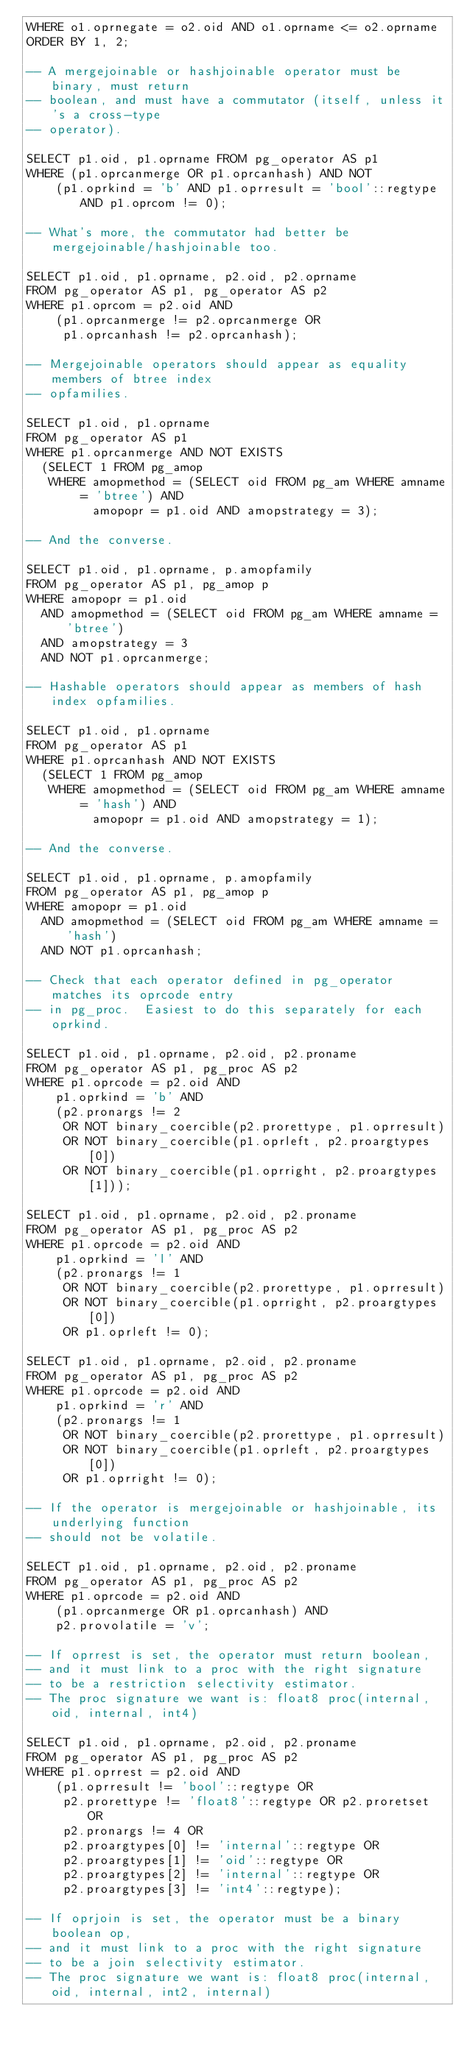<code> <loc_0><loc_0><loc_500><loc_500><_SQL_>WHERE o1.oprnegate = o2.oid AND o1.oprname <= o2.oprname
ORDER BY 1, 2;

-- A mergejoinable or hashjoinable operator must be binary, must return
-- boolean, and must have a commutator (itself, unless it's a cross-type
-- operator).

SELECT p1.oid, p1.oprname FROM pg_operator AS p1
WHERE (p1.oprcanmerge OR p1.oprcanhash) AND NOT
    (p1.oprkind = 'b' AND p1.oprresult = 'bool'::regtype AND p1.oprcom != 0);

-- What's more, the commutator had better be mergejoinable/hashjoinable too.

SELECT p1.oid, p1.oprname, p2.oid, p2.oprname
FROM pg_operator AS p1, pg_operator AS p2
WHERE p1.oprcom = p2.oid AND
    (p1.oprcanmerge != p2.oprcanmerge OR
     p1.oprcanhash != p2.oprcanhash);

-- Mergejoinable operators should appear as equality members of btree index
-- opfamilies.

SELECT p1.oid, p1.oprname
FROM pg_operator AS p1
WHERE p1.oprcanmerge AND NOT EXISTS
  (SELECT 1 FROM pg_amop
   WHERE amopmethod = (SELECT oid FROM pg_am WHERE amname = 'btree') AND
         amopopr = p1.oid AND amopstrategy = 3);

-- And the converse.

SELECT p1.oid, p1.oprname, p.amopfamily
FROM pg_operator AS p1, pg_amop p
WHERE amopopr = p1.oid
  AND amopmethod = (SELECT oid FROM pg_am WHERE amname = 'btree')
  AND amopstrategy = 3
  AND NOT p1.oprcanmerge;

-- Hashable operators should appear as members of hash index opfamilies.

SELECT p1.oid, p1.oprname
FROM pg_operator AS p1
WHERE p1.oprcanhash AND NOT EXISTS
  (SELECT 1 FROM pg_amop
   WHERE amopmethod = (SELECT oid FROM pg_am WHERE amname = 'hash') AND
         amopopr = p1.oid AND amopstrategy = 1);

-- And the converse.

SELECT p1.oid, p1.oprname, p.amopfamily
FROM pg_operator AS p1, pg_amop p
WHERE amopopr = p1.oid
  AND amopmethod = (SELECT oid FROM pg_am WHERE amname = 'hash')
  AND NOT p1.oprcanhash;

-- Check that each operator defined in pg_operator matches its oprcode entry
-- in pg_proc.  Easiest to do this separately for each oprkind.

SELECT p1.oid, p1.oprname, p2.oid, p2.proname
FROM pg_operator AS p1, pg_proc AS p2
WHERE p1.oprcode = p2.oid AND
    p1.oprkind = 'b' AND
    (p2.pronargs != 2
     OR NOT binary_coercible(p2.prorettype, p1.oprresult)
     OR NOT binary_coercible(p1.oprleft, p2.proargtypes[0])
     OR NOT binary_coercible(p1.oprright, p2.proargtypes[1]));

SELECT p1.oid, p1.oprname, p2.oid, p2.proname
FROM pg_operator AS p1, pg_proc AS p2
WHERE p1.oprcode = p2.oid AND
    p1.oprkind = 'l' AND
    (p2.pronargs != 1
     OR NOT binary_coercible(p2.prorettype, p1.oprresult)
     OR NOT binary_coercible(p1.oprright, p2.proargtypes[0])
     OR p1.oprleft != 0);

SELECT p1.oid, p1.oprname, p2.oid, p2.proname
FROM pg_operator AS p1, pg_proc AS p2
WHERE p1.oprcode = p2.oid AND
    p1.oprkind = 'r' AND
    (p2.pronargs != 1
     OR NOT binary_coercible(p2.prorettype, p1.oprresult)
     OR NOT binary_coercible(p1.oprleft, p2.proargtypes[0])
     OR p1.oprright != 0);

-- If the operator is mergejoinable or hashjoinable, its underlying function
-- should not be volatile.

SELECT p1.oid, p1.oprname, p2.oid, p2.proname
FROM pg_operator AS p1, pg_proc AS p2
WHERE p1.oprcode = p2.oid AND
    (p1.oprcanmerge OR p1.oprcanhash) AND
    p2.provolatile = 'v';

-- If oprrest is set, the operator must return boolean,
-- and it must link to a proc with the right signature
-- to be a restriction selectivity estimator.
-- The proc signature we want is: float8 proc(internal, oid, internal, int4)

SELECT p1.oid, p1.oprname, p2.oid, p2.proname
FROM pg_operator AS p1, pg_proc AS p2
WHERE p1.oprrest = p2.oid AND
    (p1.oprresult != 'bool'::regtype OR
     p2.prorettype != 'float8'::regtype OR p2.proretset OR
     p2.pronargs != 4 OR
     p2.proargtypes[0] != 'internal'::regtype OR
     p2.proargtypes[1] != 'oid'::regtype OR
     p2.proargtypes[2] != 'internal'::regtype OR
     p2.proargtypes[3] != 'int4'::regtype);

-- If oprjoin is set, the operator must be a binary boolean op,
-- and it must link to a proc with the right signature
-- to be a join selectivity estimator.
-- The proc signature we want is: float8 proc(internal, oid, internal, int2, internal)</code> 